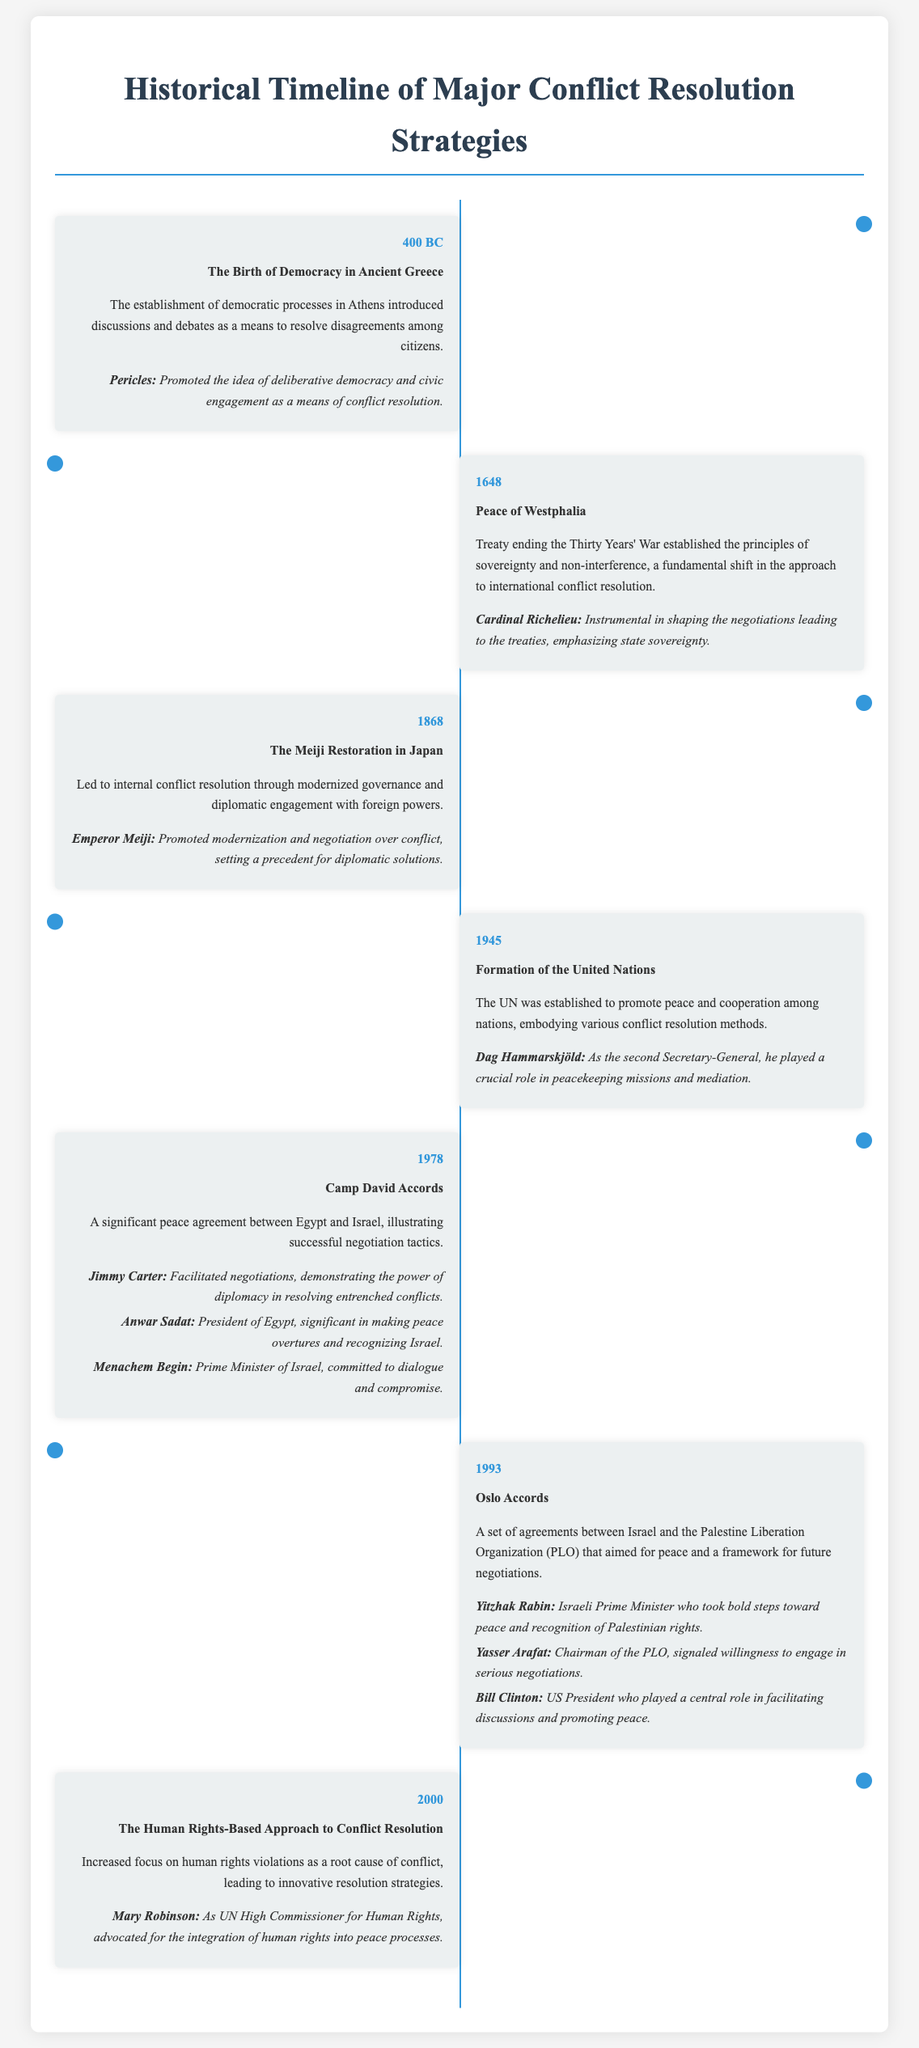What year marked the establishment of democratic processes in Athens? The document states that the establishment of democratic processes in Athens occurred in 400 BC.
Answer: 400 BC Who was instrumental in shaping the negotiations for the Peace of Westphalia? Cardinal Richelieu is mentioned as being instrumental in shaping the negotiations leading to the treaties of the Peace of Westphalia.
Answer: Cardinal Richelieu What significant event occurred in 1945? The document lists the formation of the United Nations as a significant event that occurred in 1945.
Answer: Formation of the United Nations Which U.S. President played a central role in facilitating the Oslo Accords? Bill Clinton is identified as the U.S. President who played a central role in facilitating discussions during the Oslo Accords.
Answer: Bill Clinton What was a key feature of the Camp David Accords in 1978? The document notes that the Camp David Accords illustrated successful negotiation tactics, highlighting its key feature.
Answer: Successful negotiation tactics Which conflict resolution strategy increased focus on human rights violations? The document states that the Human Rights-Based Approach to Conflict Resolution increased focus on human rights violations as a root cause of conflict.
Answer: Human Rights-Based Approach How did Emperor Meiji contribute to conflict resolution in Japan? The document says that Emperor Meiji promoted modernization and negotiation over conflict, contributing to conflict resolution in Japan.
Answer: Modernization and negotiation What principle was emphasized by Cardinal Richelieu in conflict resolution? The document indicates that Cardinal Richelieu emphasized state sovereignty as a principle in conflict resolution.
Answer: State sovereignty What type of event do the Oslo Accords represent? The document categorizes the Oslo Accords as a set of agreements between Israel and the Palestine Liberation Organization aiming for peace.
Answer: A set of agreements 